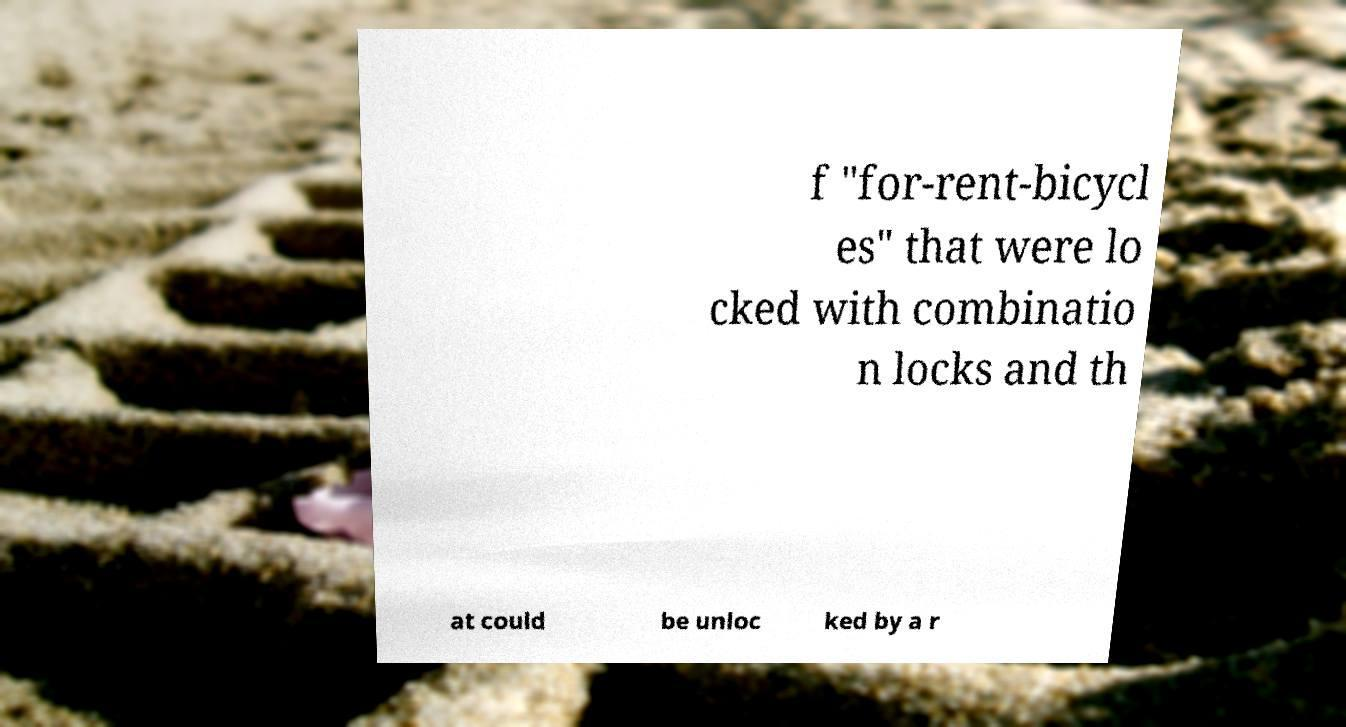For documentation purposes, I need the text within this image transcribed. Could you provide that? f "for-rent-bicycl es" that were lo cked with combinatio n locks and th at could be unloc ked by a r 